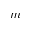Convert formula to latex. <formula><loc_0><loc_0><loc_500><loc_500>m</formula> 